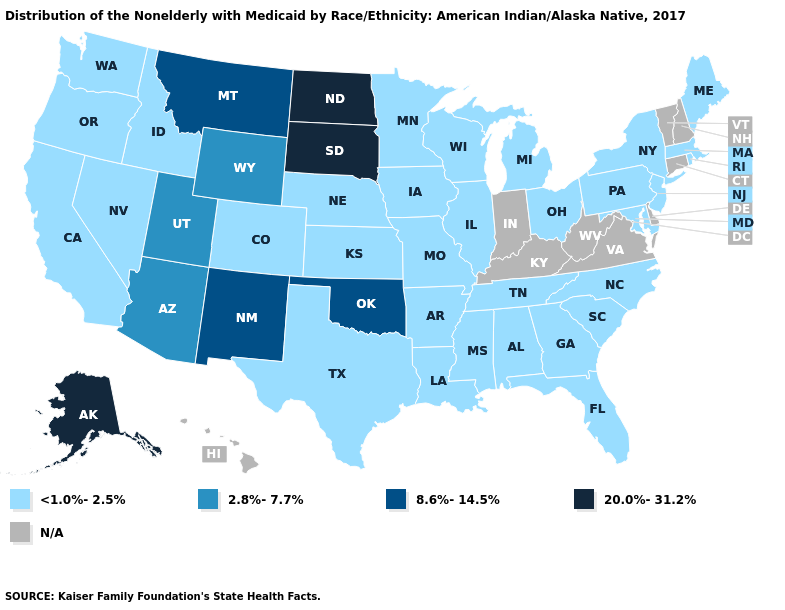Name the states that have a value in the range 20.0%-31.2%?
Quick response, please. Alaska, North Dakota, South Dakota. What is the value of Colorado?
Concise answer only. <1.0%-2.5%. Name the states that have a value in the range <1.0%-2.5%?
Short answer required. Alabama, Arkansas, California, Colorado, Florida, Georgia, Idaho, Illinois, Iowa, Kansas, Louisiana, Maine, Maryland, Massachusetts, Michigan, Minnesota, Mississippi, Missouri, Nebraska, Nevada, New Jersey, New York, North Carolina, Ohio, Oregon, Pennsylvania, Rhode Island, South Carolina, Tennessee, Texas, Washington, Wisconsin. What is the lowest value in the MidWest?
Write a very short answer. <1.0%-2.5%. Which states have the highest value in the USA?
Concise answer only. Alaska, North Dakota, South Dakota. What is the lowest value in the Northeast?
Concise answer only. <1.0%-2.5%. What is the lowest value in states that border Louisiana?
Concise answer only. <1.0%-2.5%. What is the highest value in the USA?
Write a very short answer. 20.0%-31.2%. Name the states that have a value in the range N/A?
Answer briefly. Connecticut, Delaware, Hawaii, Indiana, Kentucky, New Hampshire, Vermont, Virginia, West Virginia. Among the states that border Missouri , does Oklahoma have the lowest value?
Write a very short answer. No. Which states have the lowest value in the USA?
Keep it brief. Alabama, Arkansas, California, Colorado, Florida, Georgia, Idaho, Illinois, Iowa, Kansas, Louisiana, Maine, Maryland, Massachusetts, Michigan, Minnesota, Mississippi, Missouri, Nebraska, Nevada, New Jersey, New York, North Carolina, Ohio, Oregon, Pennsylvania, Rhode Island, South Carolina, Tennessee, Texas, Washington, Wisconsin. Among the states that border Missouri , which have the highest value?
Short answer required. Oklahoma. Does North Dakota have the highest value in the MidWest?
Be succinct. Yes. Does South Dakota have the highest value in the USA?
Quick response, please. Yes. Which states have the highest value in the USA?
Give a very brief answer. Alaska, North Dakota, South Dakota. 